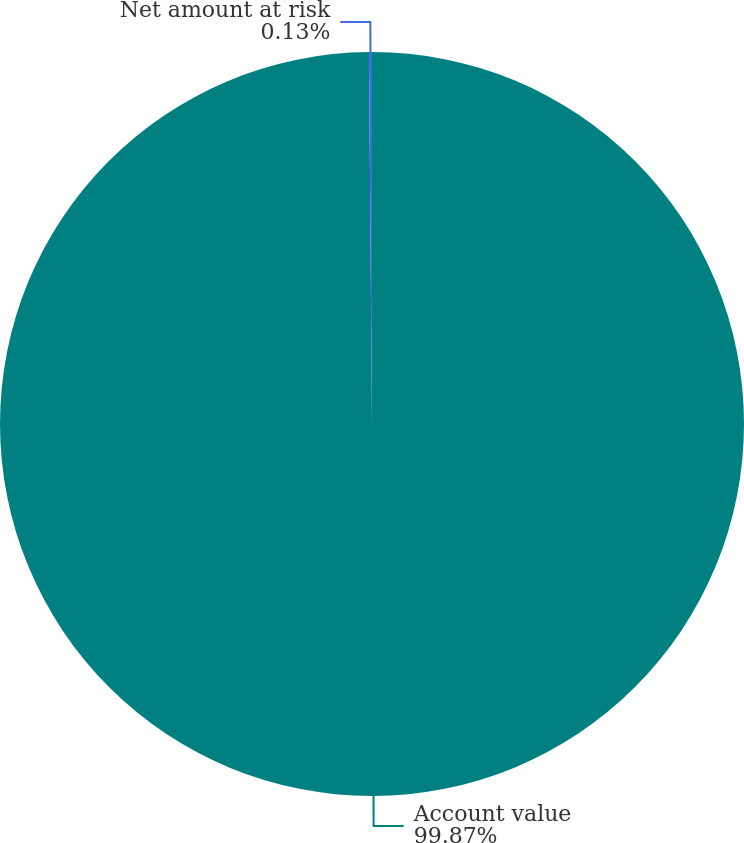Convert chart. <chart><loc_0><loc_0><loc_500><loc_500><pie_chart><fcel>Account value<fcel>Net amount at risk<nl><fcel>99.87%<fcel>0.13%<nl></chart> 